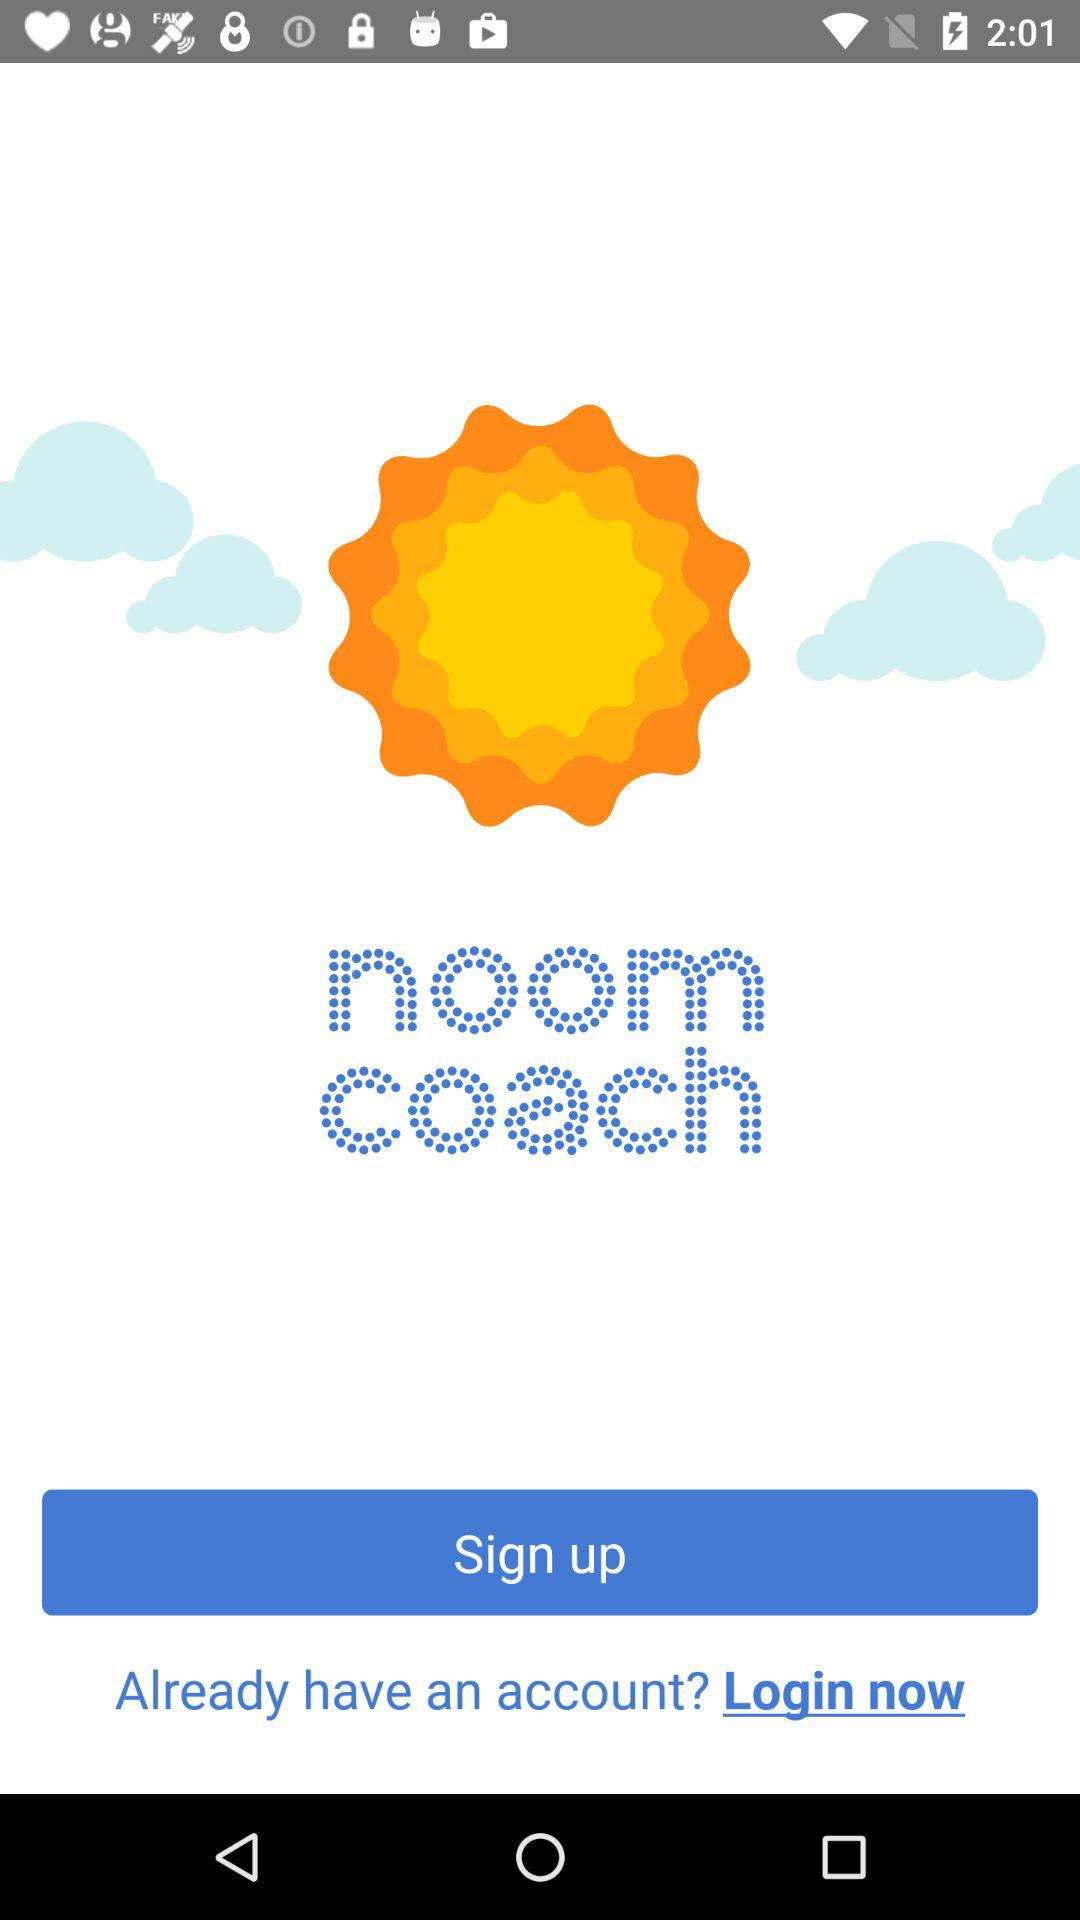What is the application name? The application name is "noom coach". 